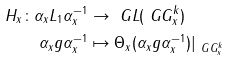<formula> <loc_0><loc_0><loc_500><loc_500>H _ { x } \colon \alpha _ { x } L _ { 1 } \alpha _ { x } ^ { - 1 } & \rightarrow \ G L ( \ G G ^ { k } _ { x } ) \\ \alpha _ { x } g \alpha _ { x } ^ { - 1 } & \mapsto \Theta _ { x } ( \alpha _ { x } g \alpha _ { x } ^ { - 1 } ) | _ { \ G G ^ { k } _ { x } }</formula> 